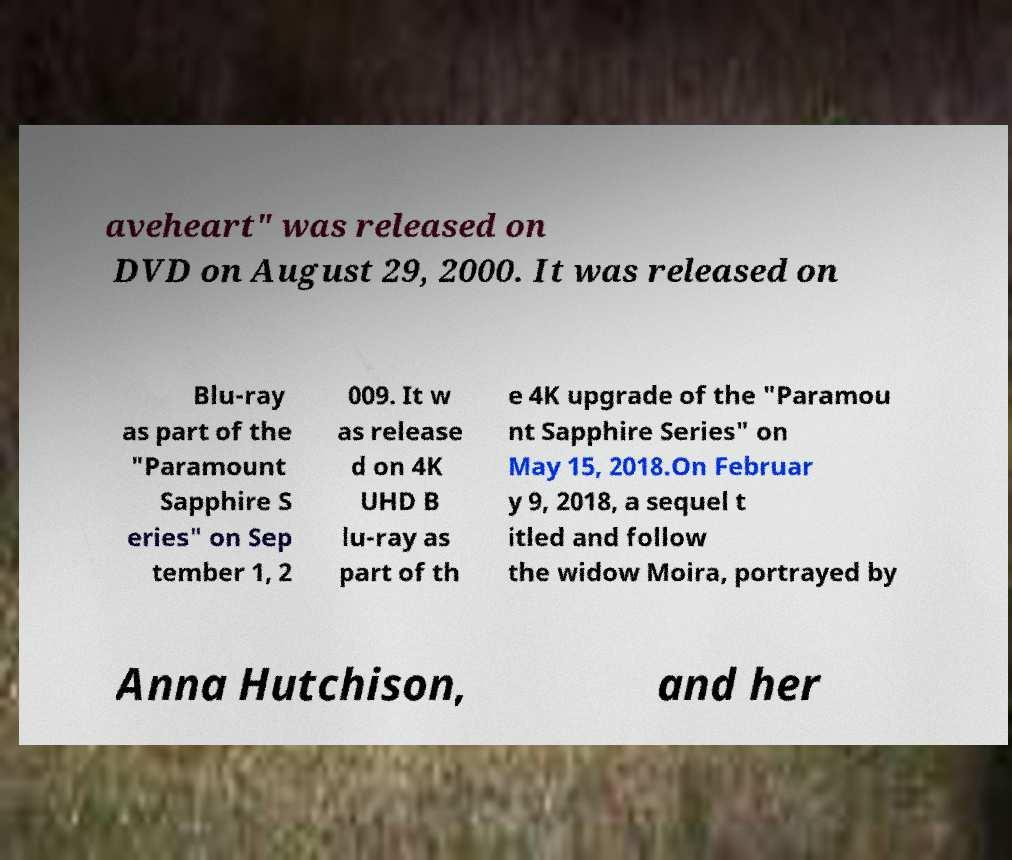Please identify and transcribe the text found in this image. aveheart" was released on DVD on August 29, 2000. It was released on Blu-ray as part of the "Paramount Sapphire S eries" on Sep tember 1, 2 009. It w as release d on 4K UHD B lu-ray as part of th e 4K upgrade of the "Paramou nt Sapphire Series" on May 15, 2018.On Februar y 9, 2018, a sequel t itled and follow the widow Moira, portrayed by Anna Hutchison, and her 